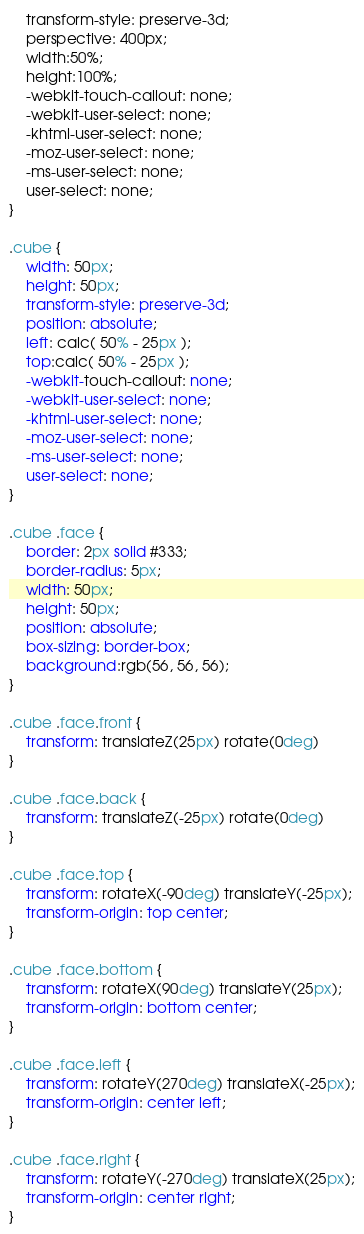Convert code to text. <code><loc_0><loc_0><loc_500><loc_500><_CSS_>    transform-style: preserve-3d;
    perspective: 400px;
    width:50%;
    height:100%;
    -webkit-touch-callout: none;
    -webkit-user-select: none;
    -khtml-user-select: none;
    -moz-user-select: none;
    -ms-user-select: none;
    user-select: none;
}

.cube {
    width: 50px;
    height: 50px;
    transform-style: preserve-3d;
    position: absolute;
    left: calc( 50% - 25px );
    top:calc( 50% - 25px );
    -webkit-touch-callout: none;
    -webkit-user-select: none;
    -khtml-user-select: none;
    -moz-user-select: none;
    -ms-user-select: none;
    user-select: none;
}

.cube .face {
    border: 2px solid #333;
    border-radius: 5px;
    width: 50px;
    height: 50px;
    position: absolute;
    box-sizing: border-box;
    background:rgb(56, 56, 56);
}

.cube .face.front {
    transform: translateZ(25px) rotate(0deg)
}

.cube .face.back {
    transform: translateZ(-25px) rotate(0deg)
}

.cube .face.top {
    transform: rotateX(-90deg) translateY(-25px);
    transform-origin: top center;
}

.cube .face.bottom {
    transform: rotateX(90deg) translateY(25px);
    transform-origin: bottom center;
}

.cube .face.left {
    transform: rotateY(270deg) translateX(-25px);
    transform-origin: center left;
}

.cube .face.right {
    transform: rotateY(-270deg) translateX(25px);
    transform-origin: center right;
}

</code> 